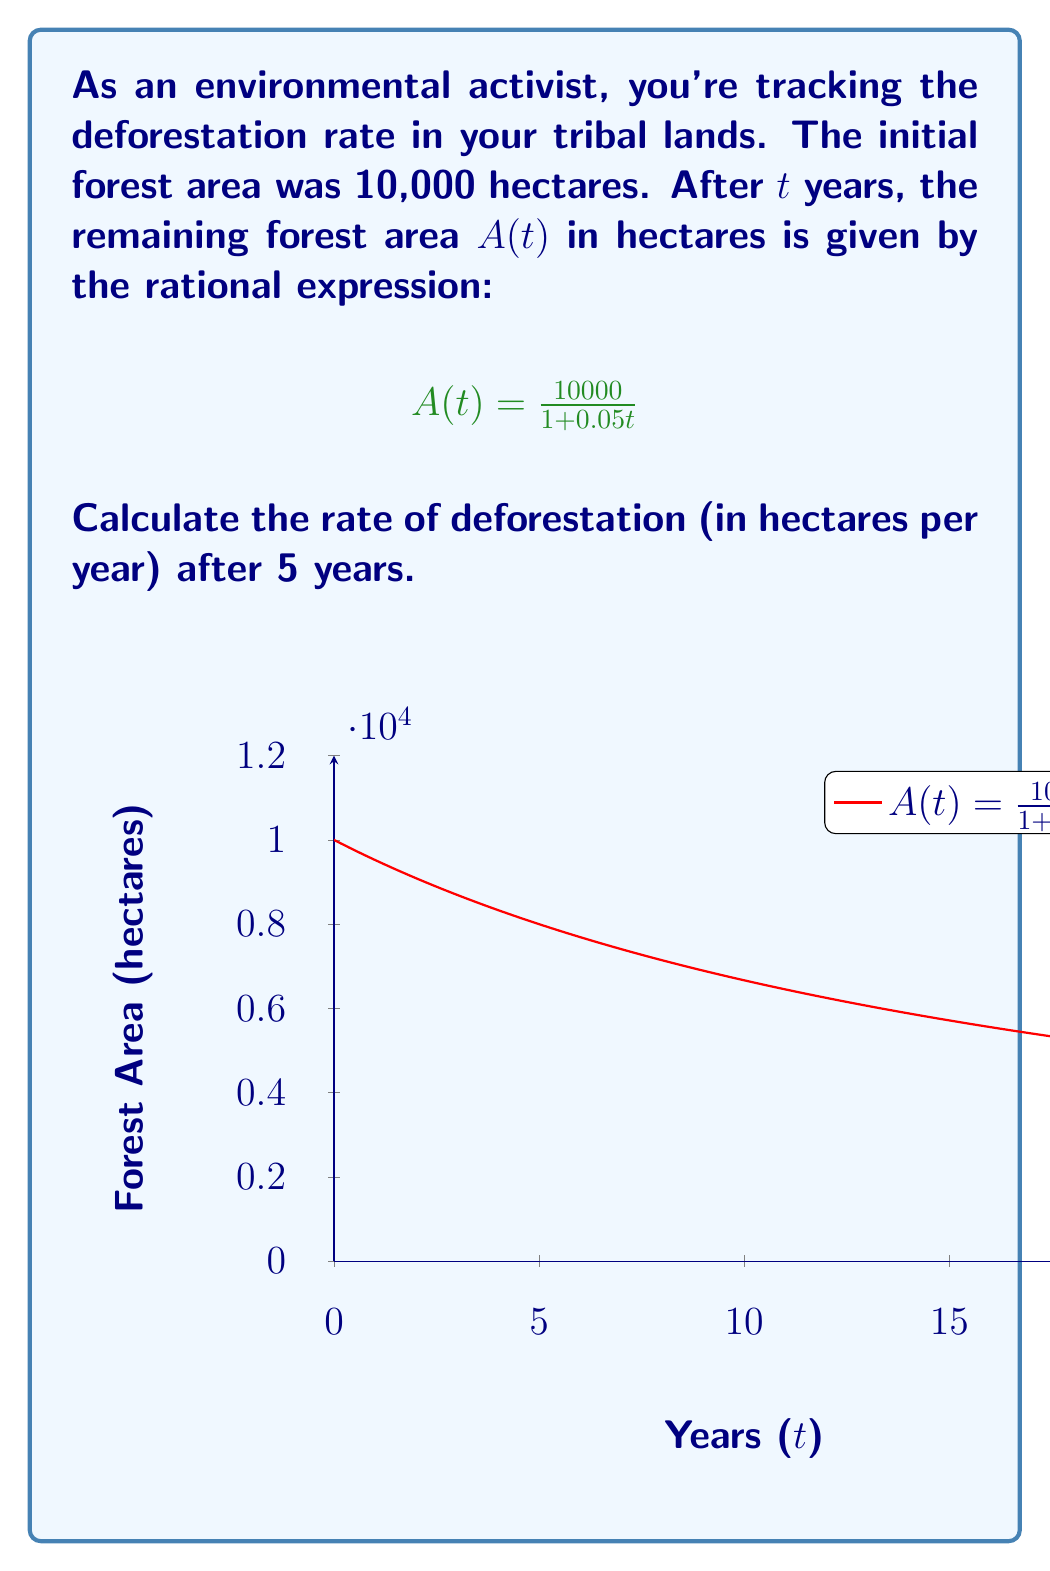Help me with this question. Let's approach this step-by-step:

1) The rate of deforestation is the negative derivative of A(t) with respect to t. We need to find $-\frac{dA}{dt}$ at t = 5.

2) To find the derivative, let's use the quotient rule:

   $$\frac{d}{dt}\left(\frac{u}{v}\right) = \frac{v\frac{du}{dt} - u\frac{dv}{dt}}{v^2}$$

3) In our case, $u = 10000$ (constant) and $v = 1 + 0.05t$

   $$\frac{dA}{dt} = \frac{(1+0.05t)\cdot 0 - 10000 \cdot 0.05}{(1+0.05t)^2}$$

4) Simplify:

   $$\frac{dA}{dt} = \frac{-500}{(1+0.05t)^2}$$

5) The rate of deforestation is the negative of this:

   $$\text{Rate of Deforestation} = \frac{500}{(1+0.05t)^2}$$

6) Now, we need to evaluate this at t = 5:

   $$\text{Rate at t = 5} = \frac{500}{(1+0.05\cdot5)^2} = \frac{500}{(1.25)^2} = \frac{500}{1.5625} = 320$$

Therefore, the rate of deforestation after 5 years is 320 hectares per year.
Answer: 320 hectares/year 